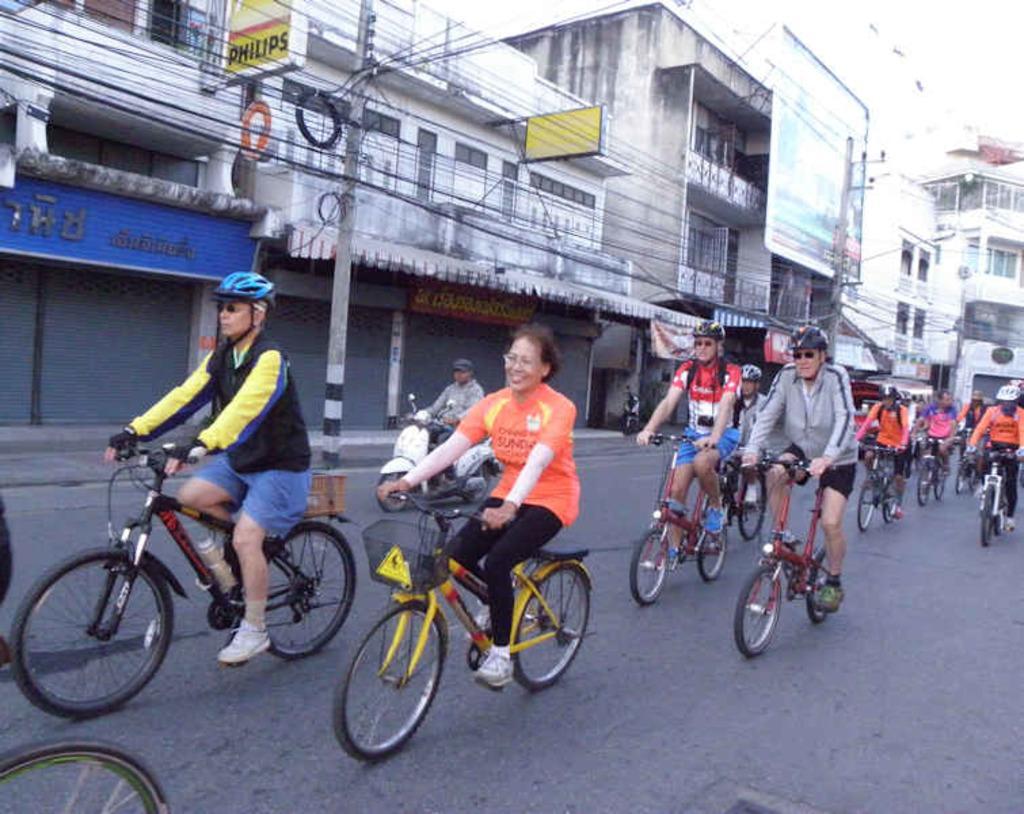Describe this image in one or two sentences. This picture is clicked outside. In the center we can see the group of persons riding bicycles and we can see a pole and cables and we can see the boards and the text on the boards. In the background we can see the building and some other objects. 